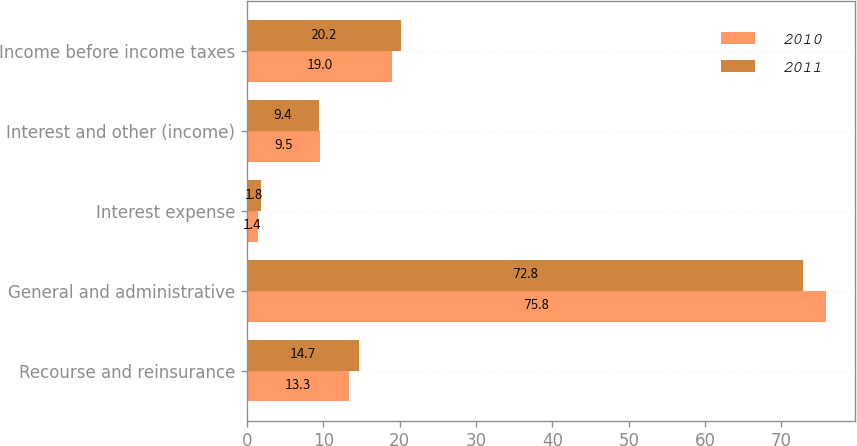Convert chart. <chart><loc_0><loc_0><loc_500><loc_500><stacked_bar_chart><ecel><fcel>Recourse and reinsurance<fcel>General and administrative<fcel>Interest expense<fcel>Interest and other (income)<fcel>Income before income taxes<nl><fcel>2010<fcel>13.3<fcel>75.8<fcel>1.4<fcel>9.5<fcel>19<nl><fcel>2011<fcel>14.7<fcel>72.8<fcel>1.8<fcel>9.4<fcel>20.2<nl></chart> 